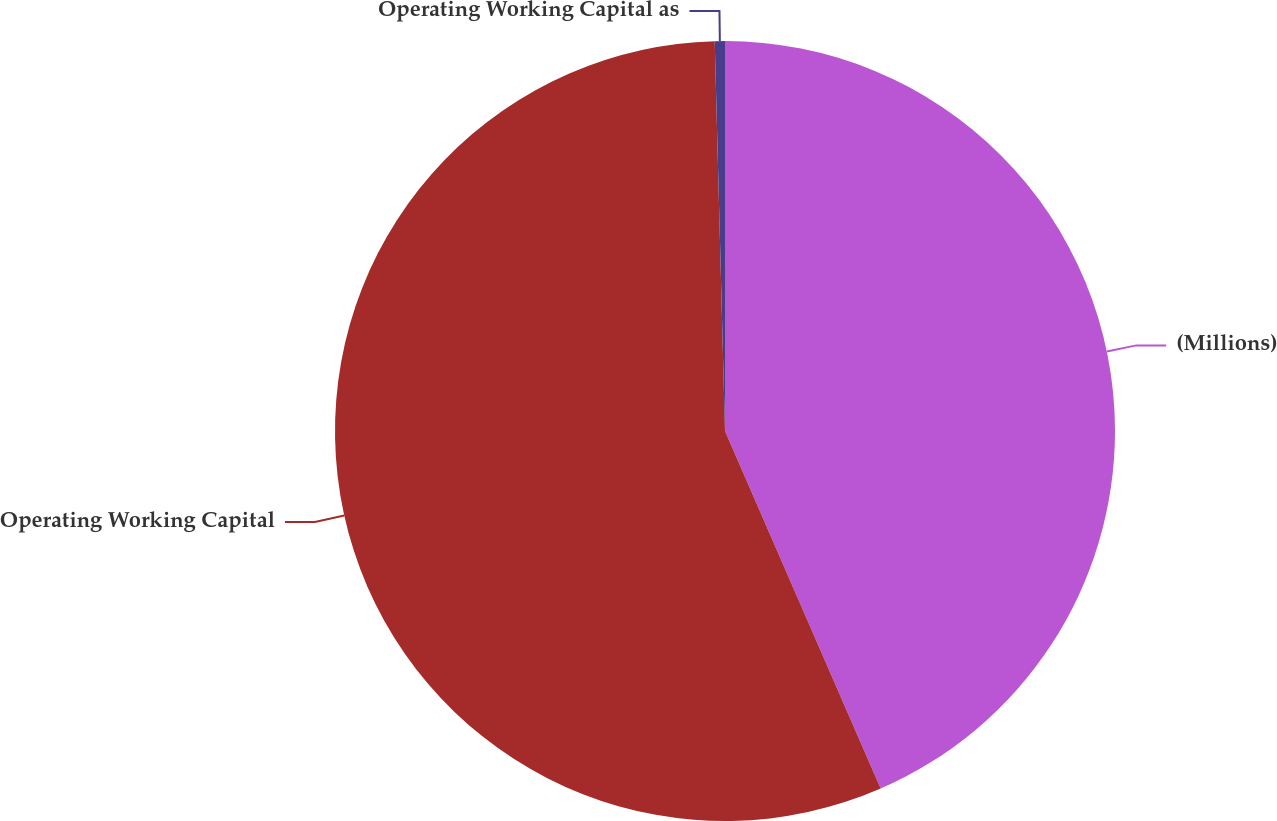Convert chart to OTSL. <chart><loc_0><loc_0><loc_500><loc_500><pie_chart><fcel>(Millions)<fcel>Operating Working Capital<fcel>Operating Working Capital as<nl><fcel>43.47%<fcel>56.12%<fcel>0.42%<nl></chart> 